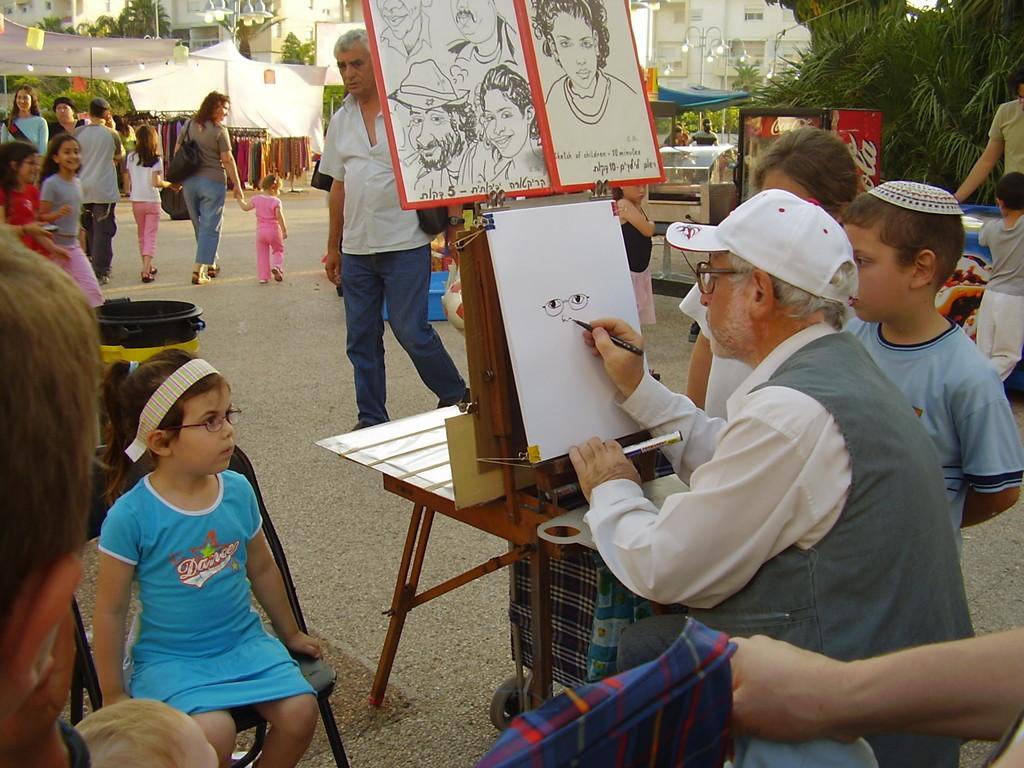Describe this image in one or two sentences. Here we can see few persons. There is a kid sitting on the chair and he is drawing on the board. Here we can see a bin, posters, table, tents, stalls, poles, and trees. In the background there are buildings. 